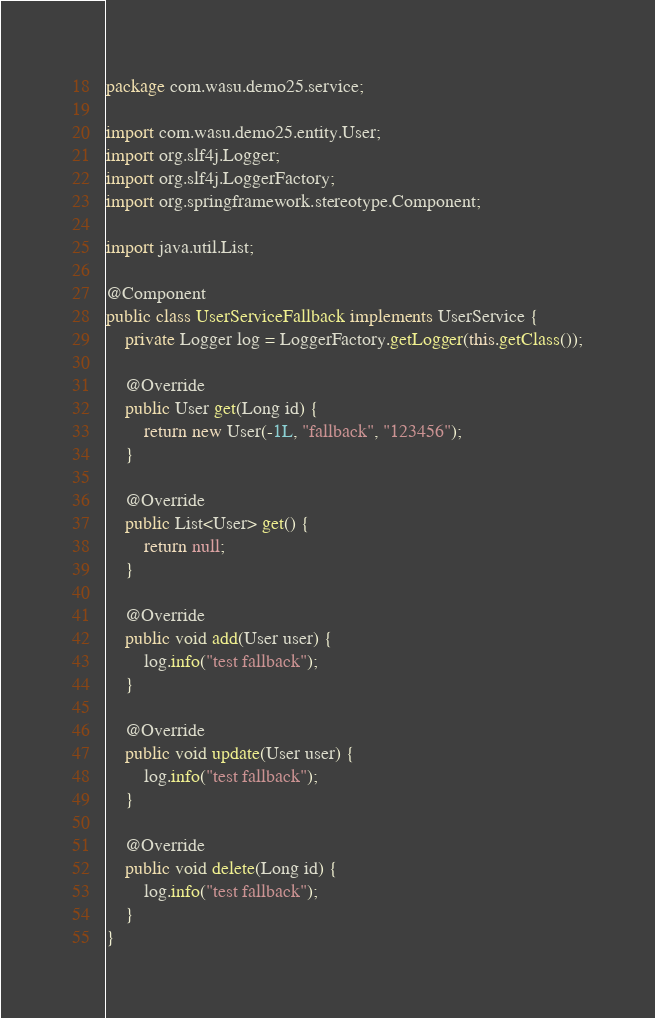<code> <loc_0><loc_0><loc_500><loc_500><_Java_>package com.wasu.demo25.service;

import com.wasu.demo25.entity.User;
import org.slf4j.Logger;
import org.slf4j.LoggerFactory;
import org.springframework.stereotype.Component;

import java.util.List;

@Component
public class UserServiceFallback implements UserService {
    private Logger log = LoggerFactory.getLogger(this.getClass());

    @Override
    public User get(Long id) {
        return new User(-1L, "fallback", "123456");
    }

    @Override
    public List<User> get() {
        return null;
    }

    @Override
    public void add(User user) {
        log.info("test fallback");
    }

    @Override
    public void update(User user) {
        log.info("test fallback");
    }

    @Override
    public void delete(Long id) {
        log.info("test fallback");
    }
}
</code> 